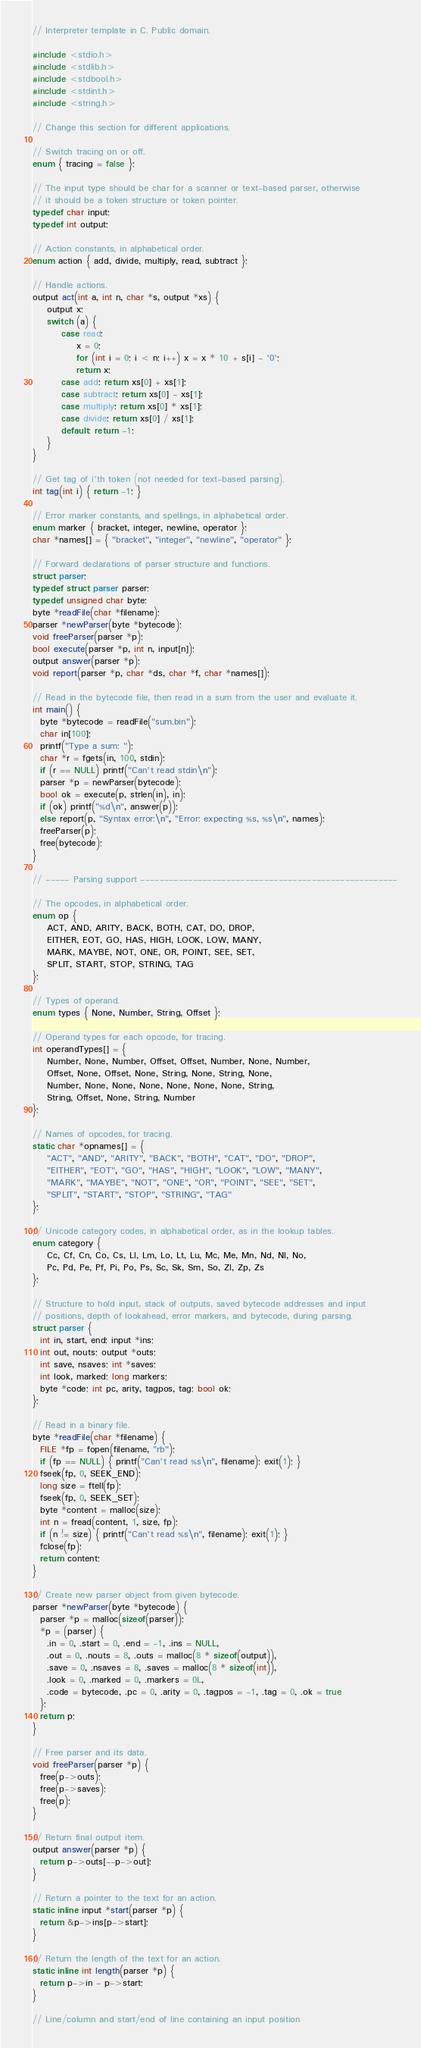<code> <loc_0><loc_0><loc_500><loc_500><_C_>// Interpreter template in C. Public domain.

#include <stdio.h>
#include <stdlib.h>
#include <stdbool.h>
#include <stdint.h>
#include <string.h>

// Change this section for different applications.

// Switch tracing on or off.
enum { tracing = false };

// The input type should be char for a scanner or text-based parser, otherwise
// it should be a token structure or token pointer.
typedef char input;
typedef int output;

// Action constants, in alphabetical order.
enum action { add, divide, multiply, read, subtract };

// Handle actions.
output act(int a, int n, char *s, output *xs) {
    output x;
    switch (a) {
        case read:
            x = 0;
            for (int i = 0; i < n; i++) x = x * 10 + s[i] - '0';
            return x;
        case add: return xs[0] + xs[1];
        case subtract: return xs[0] - xs[1];
        case multiply: return xs[0] * xs[1];
        case divide: return xs[0] / xs[1];
        default: return -1;
    }
}

// Get tag of i'th token (not needed for text-based parsing).
int tag(int i) { return -1; }

// Error marker constants, and spellings, in alphabetical order.
enum marker { bracket, integer, newline, operator };
char *names[] = { "bracket", "integer", "newline", "operator" };

// Forward declarations of parser structure and functions.
struct parser;
typedef struct parser parser;
typedef unsigned char byte;
byte *readFile(char *filename);
parser *newParser(byte *bytecode);
void freeParser(parser *p);
bool execute(parser *p, int n, input[n]);
output answer(parser *p);
void report(parser *p, char *ds, char *f, char *names[]);

// Read in the bytecode file, then read in a sum from the user and evaluate it.
int main() {
  byte *bytecode = readFile("sum.bin");
  char in[100];
  printf("Type a sum: ");
  char *r = fgets(in, 100, stdin);
  if (r == NULL) printf("Can't read stdin\n");
  parser *p = newParser(bytecode);
  bool ok = execute(p, strlen(in), in);
  if (ok) printf("%d\n", answer(p));
  else report(p, "Syntax error:\n", "Error: expecting %s, %s\n", names);
  freeParser(p);
  free(bytecode);
}

// ----- Parsing support ------------------------------------------------------

// The opcodes, in alphabetical order.
enum op {
    ACT, AND, ARITY, BACK, BOTH, CAT, DO, DROP,
    EITHER, EOT, GO, HAS, HIGH, LOOK, LOW, MANY,
    MARK, MAYBE, NOT, ONE, OR, POINT, SEE, SET,
    SPLIT, START, STOP, STRING, TAG
};

// Types of operand.
enum types { None, Number, String, Offset };

// Operand types for each opcode, for tracing.
int operandTypes[] = {
    Number, None, Number, Offset, Offset, Number, None, Number,
    Offset, None, Offset, None, String, None, String, None,
    Number, None, None, None, None, None, None, String,
    String, Offset, None, String, Number
};

// Names of opcodes, for tracing.
static char *opnames[] = {
    "ACT", "AND", "ARITY", "BACK", "BOTH", "CAT", "DO", "DROP",
    "EITHER", "EOT", "GO", "HAS", "HIGH", "LOOK", "LOW", "MANY",
    "MARK", "MAYBE", "NOT", "ONE", "OR", "POINT", "SEE", "SET",
    "SPLIT", "START", "STOP", "STRING", "TAG"
};

// Unicode category codes, in alphabetical order, as in the lookup tables.
enum category {
    Cc, Cf, Cn, Co, Cs, Ll, Lm, Lo, Lt, Lu, Mc, Me, Mn, Nd, Nl, No,
    Pc, Pd, Pe, Pf, Pi, Po, Ps, Sc, Sk, Sm, So, Zl, Zp, Zs
};

// Structure to hold input, stack of outputs, saved bytecode addresses and input
// positions, depth of lookahead, error markers, and bytecode, during parsing.
struct parser {
  int in, start, end; input *ins;
  int out, nouts; output *outs;
  int save, nsaves; int *saves;
  int look, marked; long markers;
  byte *code; int pc, arity, tagpos, tag; bool ok;
};

// Read in a binary file.
byte *readFile(char *filename) {
  FILE *fp = fopen(filename, "rb");
  if (fp == NULL) { printf("Can't read %s\n", filename); exit(1); }
  fseek(fp, 0, SEEK_END);
  long size = ftell(fp);
  fseek(fp, 0, SEEK_SET);
  byte *content = malloc(size);
  int n = fread(content, 1, size, fp);
  if (n != size) { printf("Can't read %s\n", filename); exit(1); }
  fclose(fp);
  return content;
}

// Create new parser object from given bytecode.
parser *newParser(byte *bytecode) {
  parser *p = malloc(sizeof(parser));
  *p = (parser) {
    .in = 0, .start = 0, .end = -1, .ins = NULL,
    .out = 0, .nouts = 8, .outs = malloc(8 * sizeof(output)),
    .save = 0, .nsaves = 8, .saves = malloc(8 * sizeof(int)),
    .look = 0, .marked = 0, .markers = 0L,
    .code = bytecode, .pc = 0, .arity = 0, .tagpos = -1, .tag = 0, .ok = true
  };
  return p;
}

// Free parser and its data.
void freeParser(parser *p) {
  free(p->outs);
  free(p->saves);
  free(p);
}

// Return final output item.
output answer(parser *p) {
  return p->outs[--p->out];
}

// Return a pointer to the text for an action.
static inline input *start(parser *p) {
  return &p->ins[p->start];
}

// Return the length of the text for an action.
static inline int length(parser *p) {
  return p->in - p->start;
}

// Line/column and start/end of line containing an input position</code> 